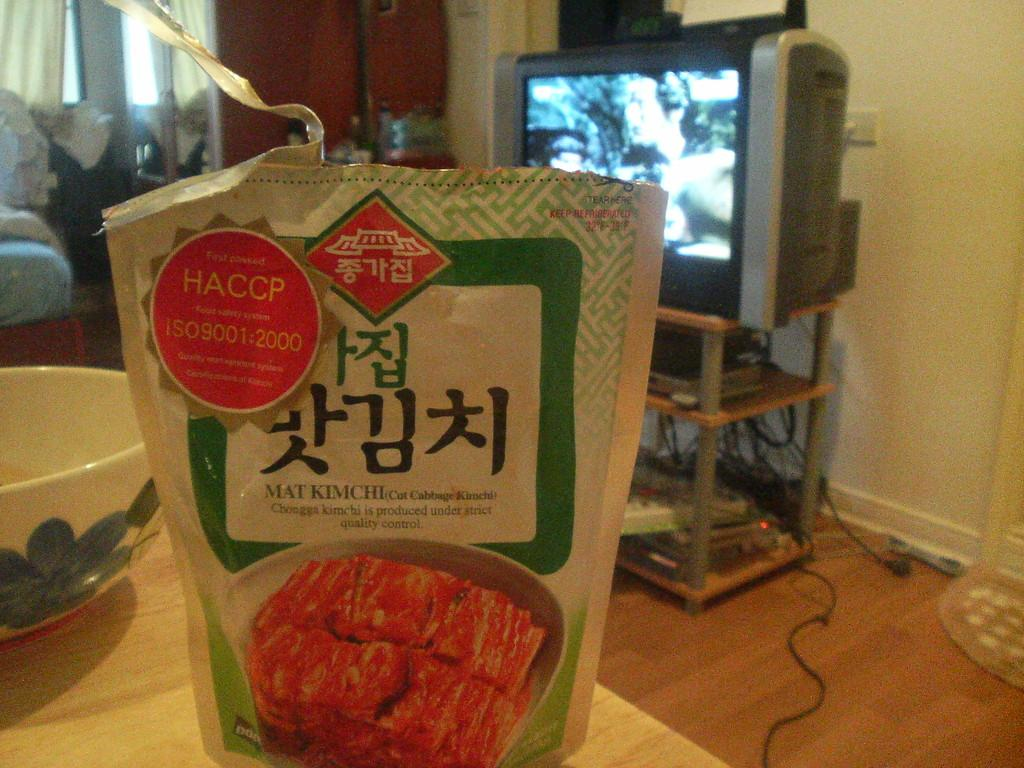<image>
Offer a succinct explanation of the picture presented. A food product sits on a table with a red circle with the word HACCP in it. 